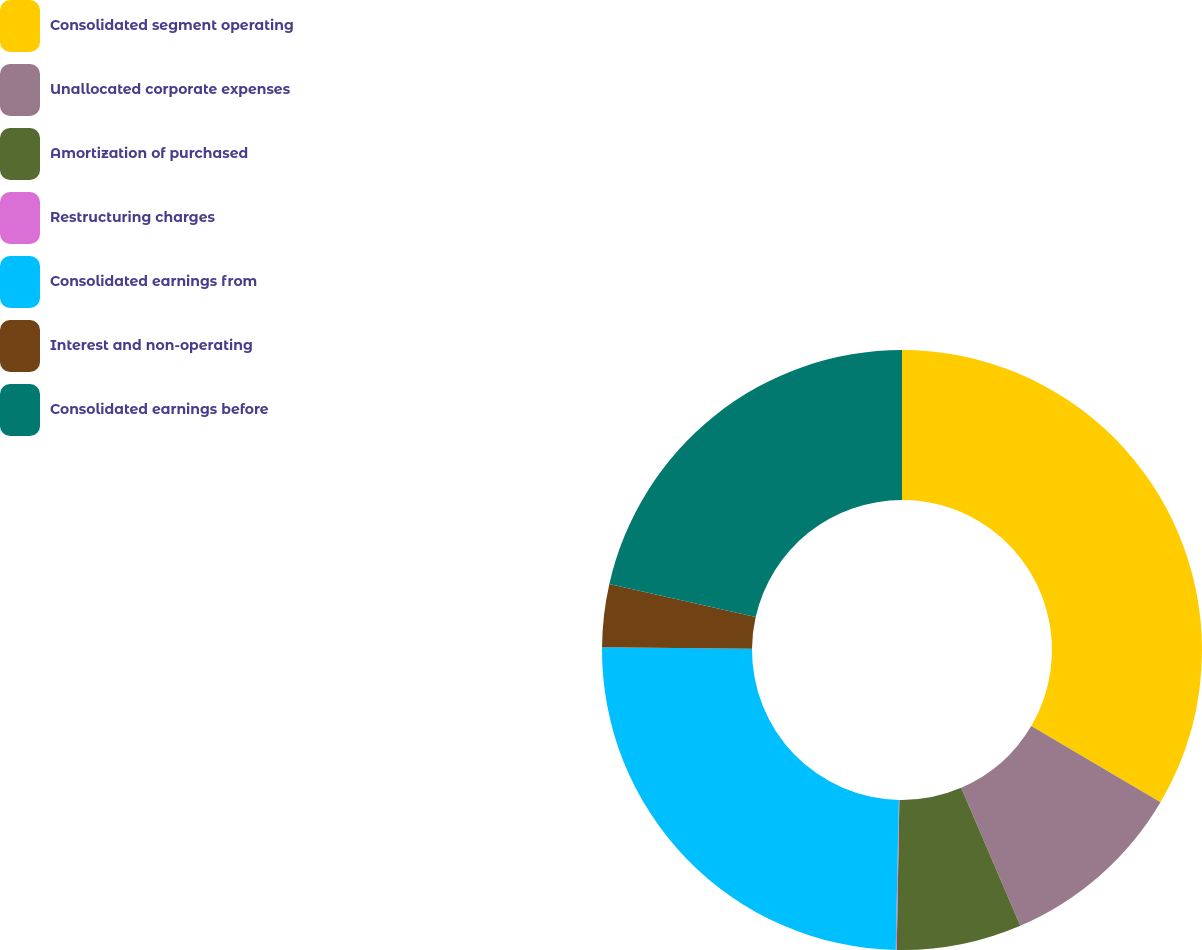Convert chart. <chart><loc_0><loc_0><loc_500><loc_500><pie_chart><fcel>Consolidated segment operating<fcel>Unallocated corporate expenses<fcel>Amortization of purchased<fcel>Restructuring charges<fcel>Consolidated earnings from<fcel>Interest and non-operating<fcel>Consolidated earnings before<nl><fcel>33.47%<fcel>10.08%<fcel>6.73%<fcel>0.05%<fcel>24.81%<fcel>3.39%<fcel>21.47%<nl></chart> 